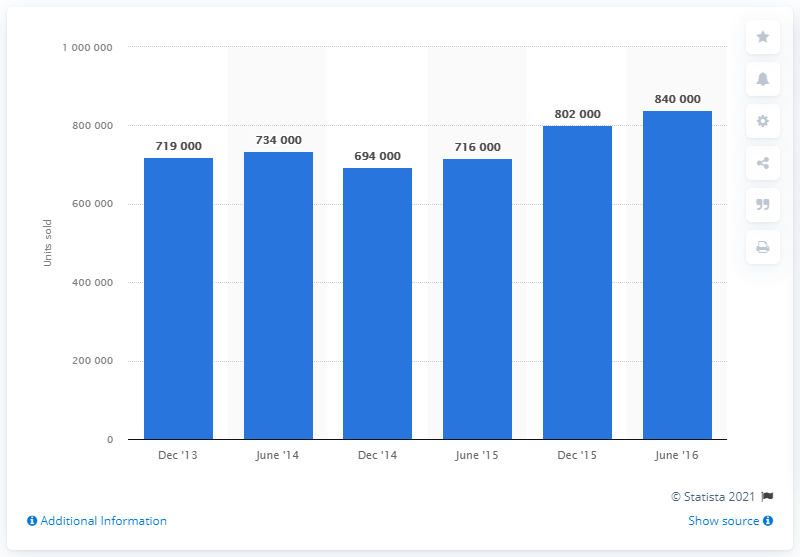Highlight a few significant elements in this photo. In France, a total of 840,000 housing units were sold between December 2013 and June 2016. 